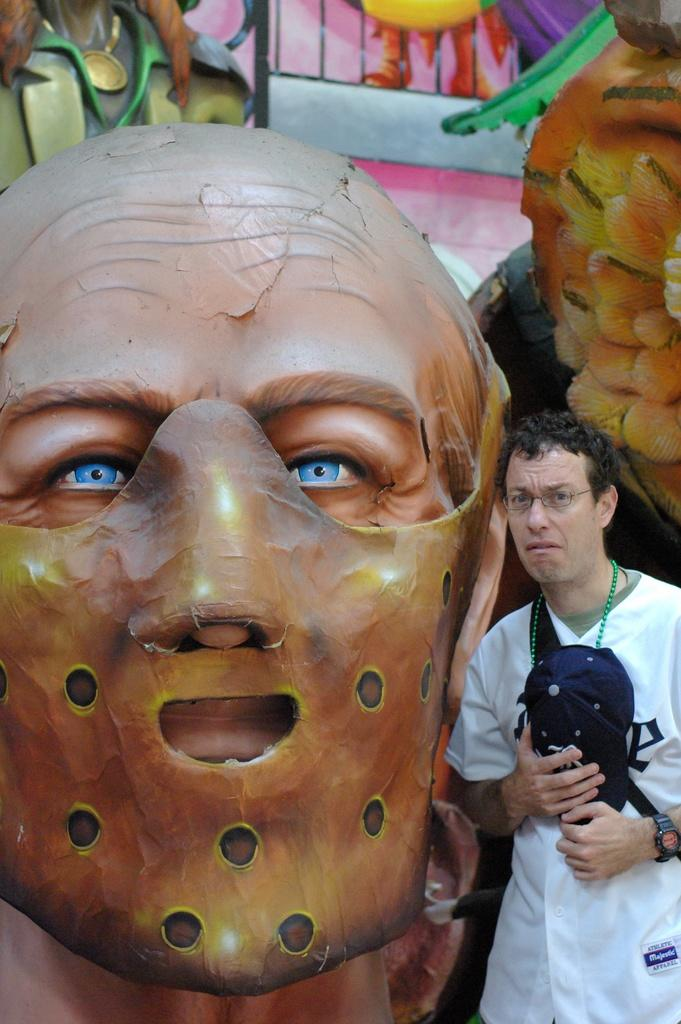Who or what is present in the image? There is a person in the image. What is the person standing beside? The person is standing beside a mask. What is the person wearing? The person is wearing a white dress and a black cap. Can you describe the wall in the image? The wall in the image is multicolored. What type of cream is being used to transport the wire in the image? There is no cream, transport, or wire present in the image. 